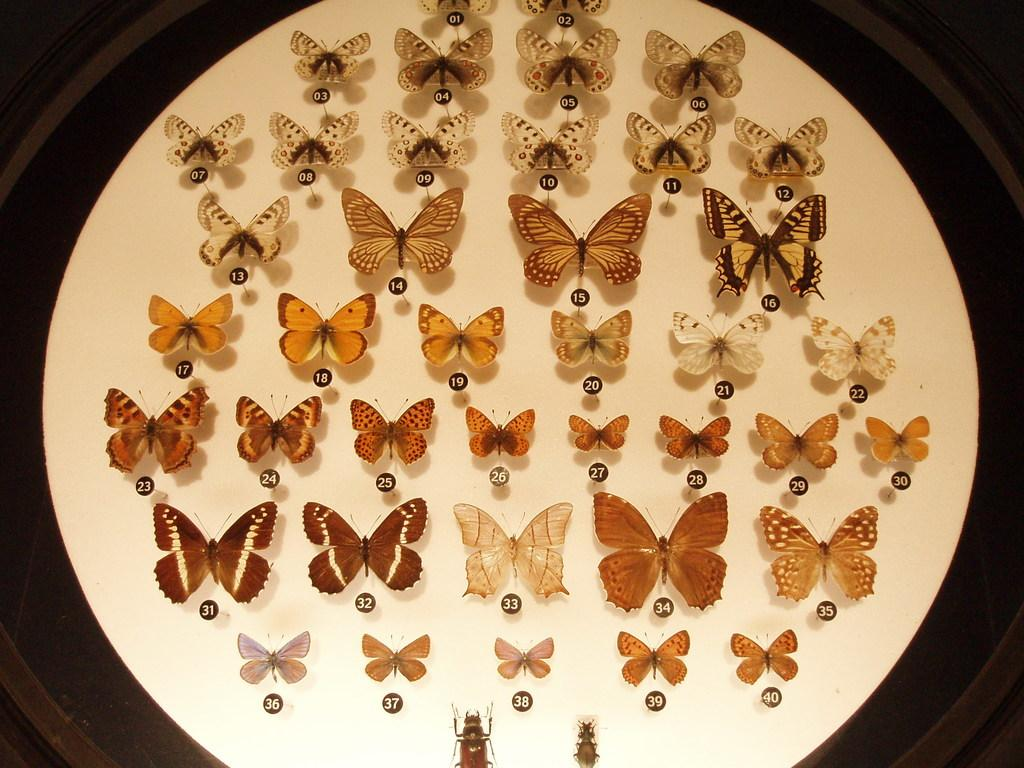What is the primary color of the surface in the image? The surface in the image is white. What types of creatures can be seen on the surface? There are different butterflies and insects on the surface. What type of muscle is visible on the surface in the image? There is no muscle visible on the surface in the image. What type of care is being provided to the creatures on the surface in the image? The image does not show any care being provided to the creatures; it only shows them on the surface. 